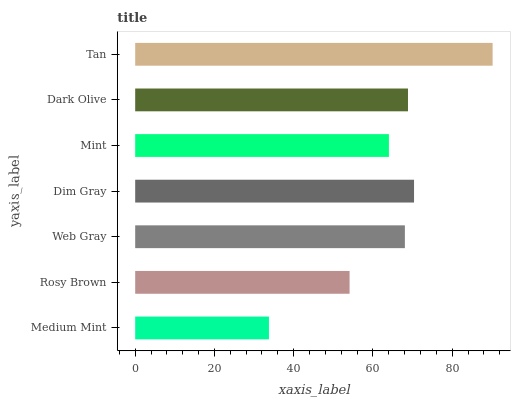Is Medium Mint the minimum?
Answer yes or no. Yes. Is Tan the maximum?
Answer yes or no. Yes. Is Rosy Brown the minimum?
Answer yes or no. No. Is Rosy Brown the maximum?
Answer yes or no. No. Is Rosy Brown greater than Medium Mint?
Answer yes or no. Yes. Is Medium Mint less than Rosy Brown?
Answer yes or no. Yes. Is Medium Mint greater than Rosy Brown?
Answer yes or no. No. Is Rosy Brown less than Medium Mint?
Answer yes or no. No. Is Web Gray the high median?
Answer yes or no. Yes. Is Web Gray the low median?
Answer yes or no. Yes. Is Rosy Brown the high median?
Answer yes or no. No. Is Dark Olive the low median?
Answer yes or no. No. 